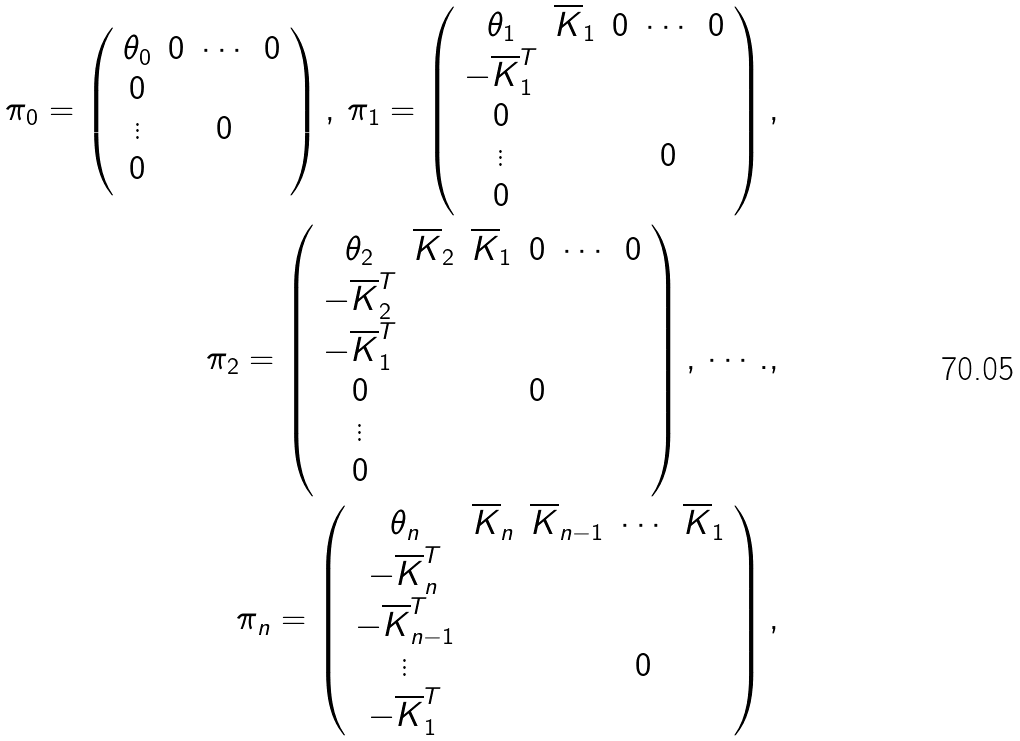<formula> <loc_0><loc_0><loc_500><loc_500>\pi _ { 0 } = \left ( \begin{array} { c c c c } \theta _ { 0 } & 0 & \cdots & 0 \\ 0 & & & \\ \vdots & & 0 & \\ 0 & & & \end{array} \right ) , \, \pi _ { 1 } = \left ( \begin{array} { c c c c c } \theta _ { 1 } & \overline { K } _ { 1 } & 0 & \cdots & 0 \\ - \overline { K } _ { 1 } ^ { T } & & & & \\ 0 & & & & \\ \vdots & & & 0 & \\ 0 & & & & \end{array} \right ) , \\ \pi _ { 2 } = \left ( \begin{array} { c c c c c c } \theta _ { 2 } & \overline { K } _ { 2 } & \overline { K } _ { 1 } & 0 & \cdots & 0 \\ - \overline { K } _ { 2 } ^ { T } & & & & & \\ - \overline { K } _ { 1 } ^ { T } & & & & & \\ 0 & & & 0 & & \\ \vdots & & & & & \\ 0 & & & & & \end{array} \right ) , \, \cdots . , \\ \pi _ { n } = \left ( \begin{array} { c c c c c } \theta _ { n } & \overline { K } _ { n } & \overline { K } _ { n - 1 } & \cdots & \overline { K } _ { 1 } \\ - \overline { K } _ { n } ^ { T } & & & & \\ - \overline { K } _ { n - 1 } ^ { T } & & & & \\ \vdots & & & 0 & \\ - \overline { K } _ { 1 } ^ { T } & & & & \end{array} \right ) ,</formula> 